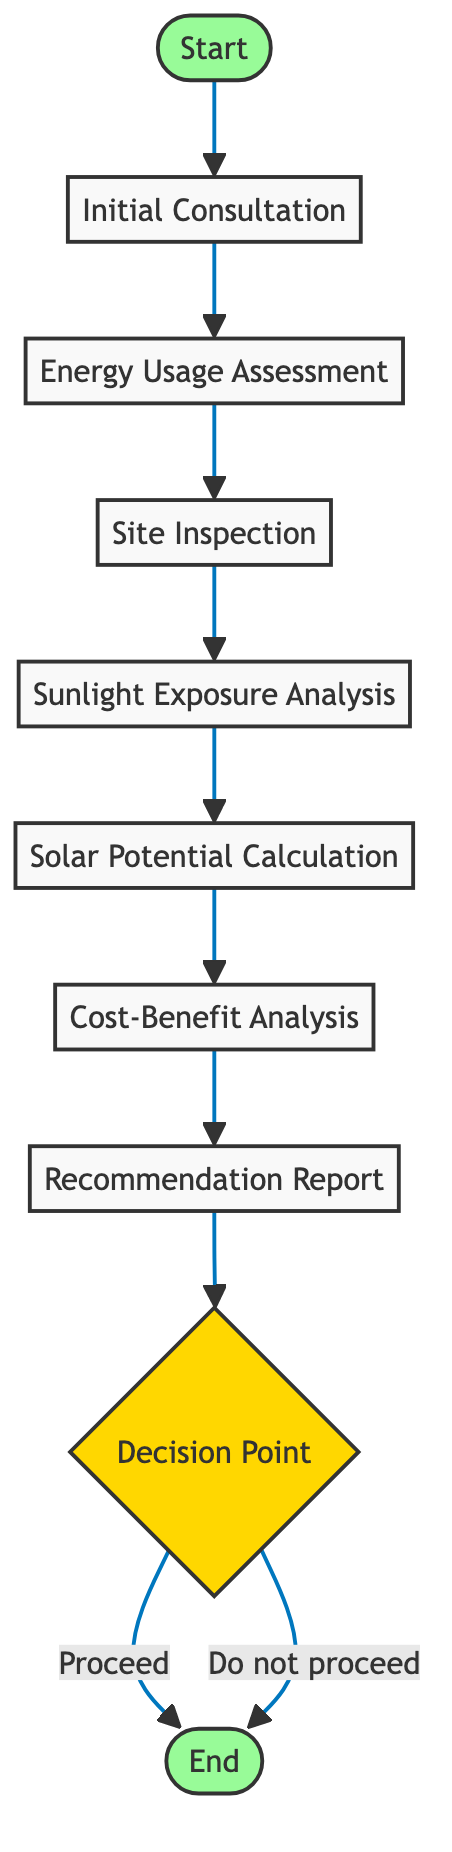What's the first step in the diagram? The diagram starts with the "Start" node, which indicates the initiation of the home energy audit process.
Answer: Start How many total nodes are present in the diagram? By counting each distinct step in the flow chart from "Start" to "End," there are a total of 10 nodes.
Answer: 10 What is the last step before the decision point? The last step before reaching the decision point is the "Recommendation Report," which contains findings and recommendations regarding solar feasibility.
Answer: Recommendation Report What action occurs after the "Cost-Benefit Analysis"? The next action after the "Cost-Benefit Analysis" is the generation of the "Recommendation Report."
Answer: Recommendation Report What are the two possible outcomes after the decision point? The two outcomes after the decision point are to either "Proceed" with the solar installation or "Do not proceed."
Answer: Proceed, Do not proceed What is the purpose of the "Solar Potential Calculation"? The "Solar Potential Calculation" node is meant to calculate the potential energy production based on sunlight exposure, which helps in understanding the viability of solar energy for the home.
Answer: Calculate potential energy production What is the transition type from "Sunlight Exposure Analysis" to "Solar Potential Calculation"? The transition from the "Sunlight Exposure Analysis" node to the "Solar Potential Calculation" node is a direct flow indicating the sequence of actions in the audit process.
Answer: Direct flow What is the type of the node labeled "Decision Point"? The node labeled "Decision Point" is a decision node, indicated by the diamond shape, which allows the homeowner to make a choice based on previous assessments.
Answer: Decision node What does the "Initial Consultation" involve? The "Initial Consultation" involves discussing energy consumption and homeowner goals, which initiates the understanding of the homeowner's needs.
Answer: Discuss energy consumption and goals 